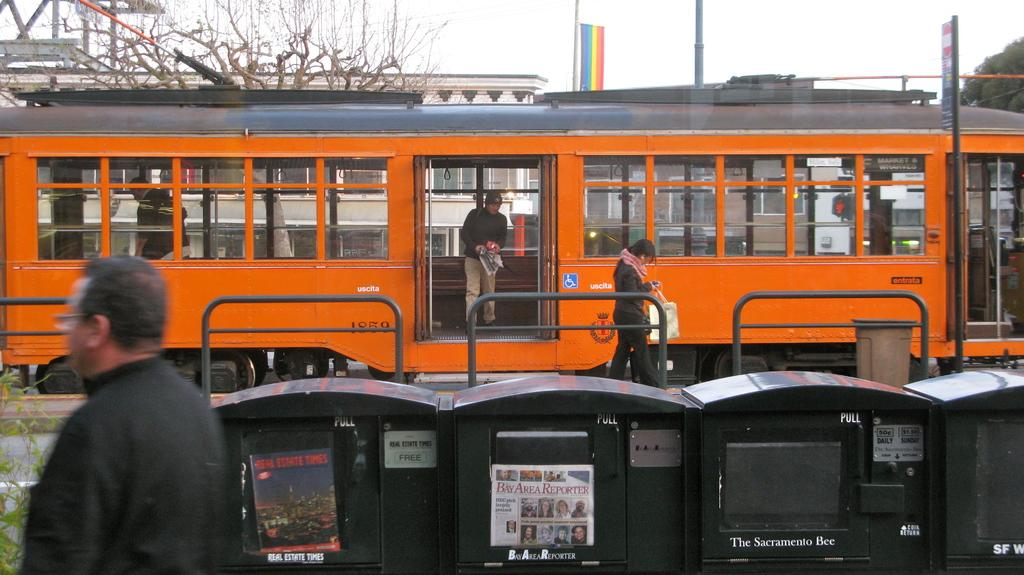How many people can be seen in the image? There are people in the image, but the exact number is not specified. What is the main mode of transportation in the image? There is a train on the railway in the image. What type of natural vegetation is present in the image? There are trees in the image. What type of barrier is present in the image? There is a fence in the image. What other objects can be seen on the ground in the image? There are other objects on the ground in the image, but their specific nature is not mentioned. What can be seen in the background of the image? The sky is visible in the background of the image, along with a banner and other objects. What type of scent can be smelled coming from the church in the image? There is no church present in the image, so it is not possible to determine what scent might be smelled. 